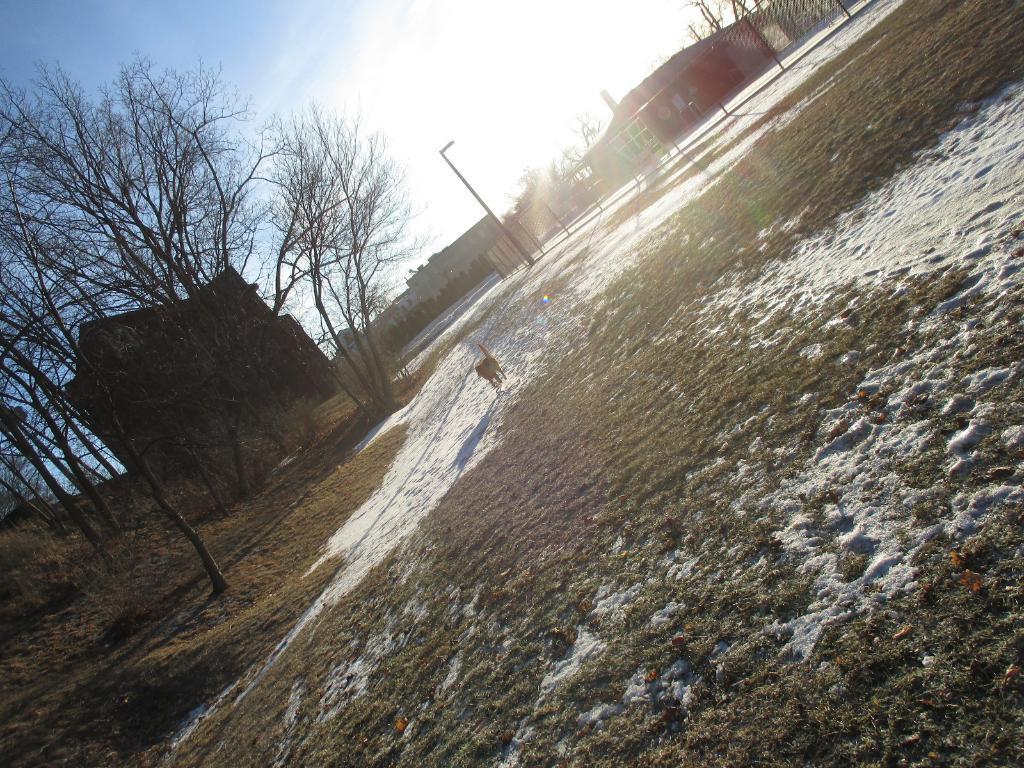Please provide a concise description of this image. In this image we can see an animal, snow and grass on the ground and on the left side we can see trees and house. In the background we can see poles, fence, trees, buildings and clouds in the sky. 